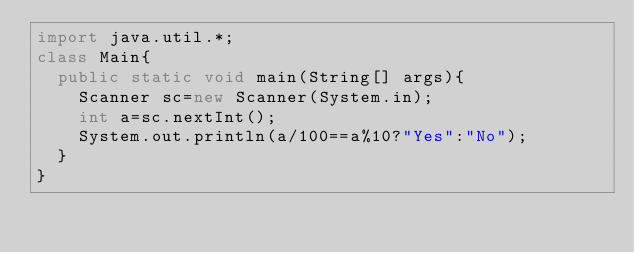Convert code to text. <code><loc_0><loc_0><loc_500><loc_500><_Java_>import java.util.*;
class Main{
  public static void main(String[] args){
    Scanner sc=new Scanner(System.in);
    int a=sc.nextInt();
    System.out.println(a/100==a%10?"Yes":"No");
  }
}
</code> 